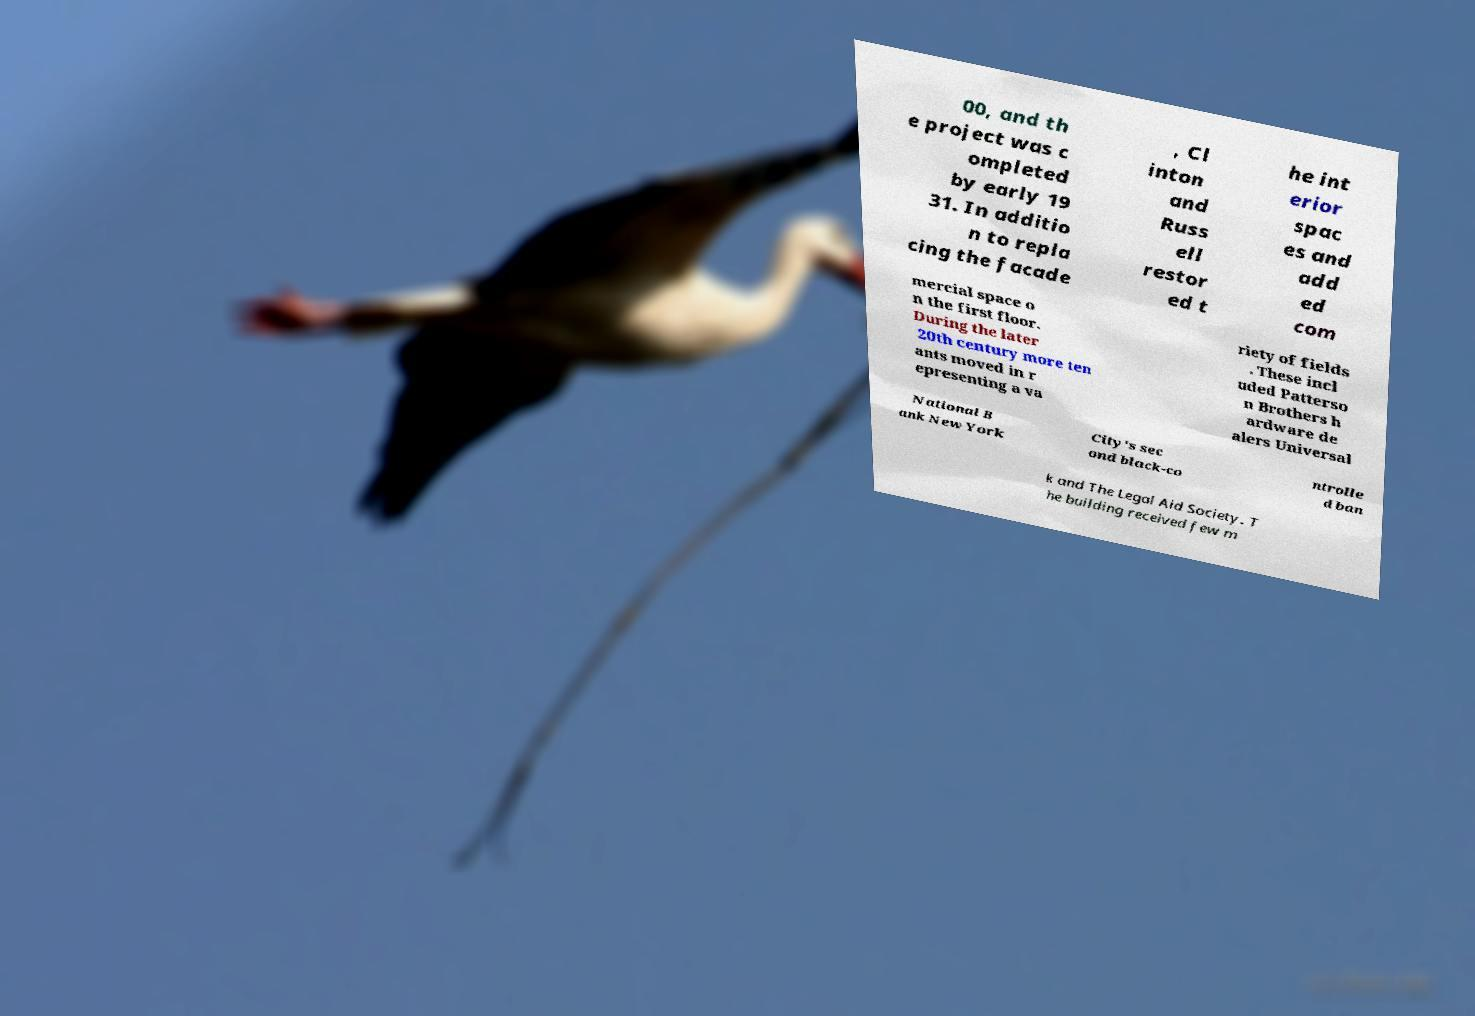There's text embedded in this image that I need extracted. Can you transcribe it verbatim? 00, and th e project was c ompleted by early 19 31. In additio n to repla cing the facade , Cl inton and Russ ell restor ed t he int erior spac es and add ed com mercial space o n the first floor. During the later 20th century more ten ants moved in r epresenting a va riety of fields . These incl uded Patterso n Brothers h ardware de alers Universal National B ank New York City's sec ond black-co ntrolle d ban k and The Legal Aid Society. T he building received few m 